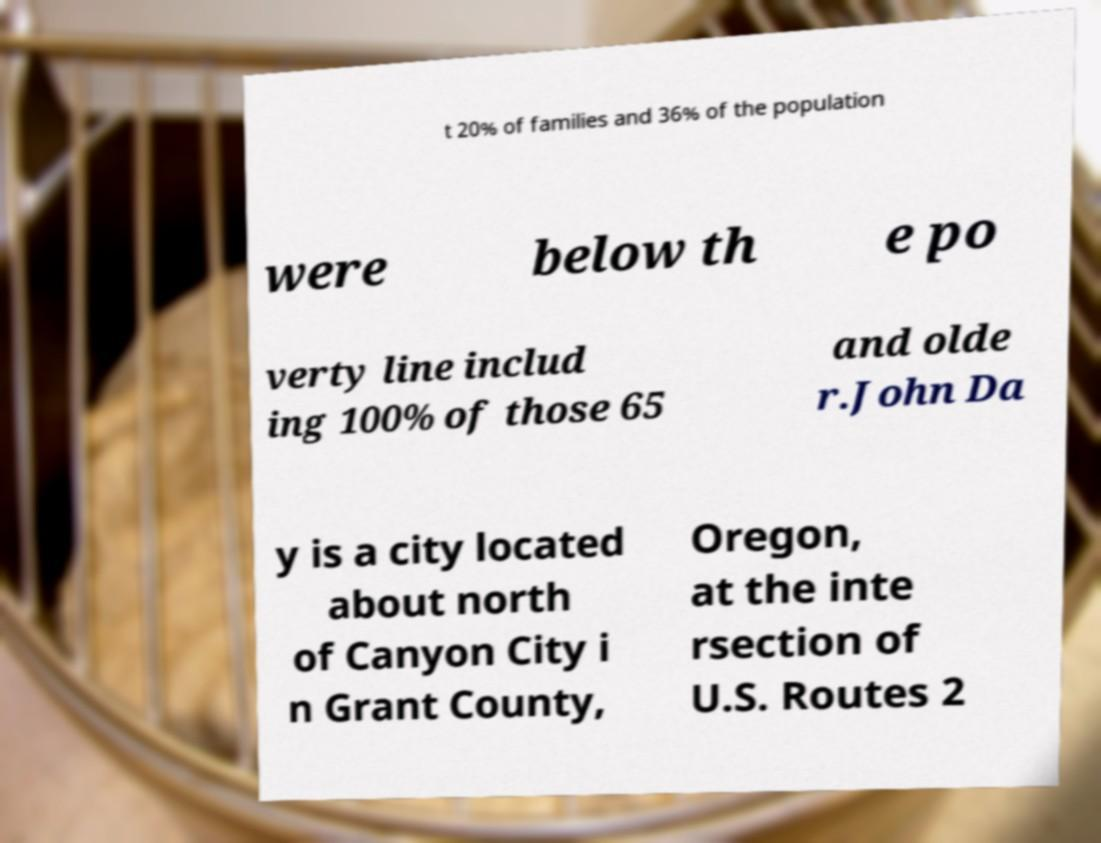What messages or text are displayed in this image? I need them in a readable, typed format. t 20% of families and 36% of the population were below th e po verty line includ ing 100% of those 65 and olde r.John Da y is a city located about north of Canyon City i n Grant County, Oregon, at the inte rsection of U.S. Routes 2 